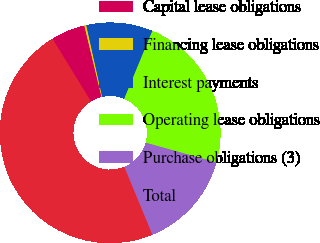<chart> <loc_0><loc_0><loc_500><loc_500><pie_chart><fcel>Capital lease obligations<fcel>Financing lease obligations<fcel>Interest payments<fcel>Operating lease obligations<fcel>Purchase obligations (3)<fcel>Total<nl><fcel>5.0%<fcel>0.29%<fcel>9.72%<fcel>23.07%<fcel>14.44%<fcel>47.47%<nl></chart> 